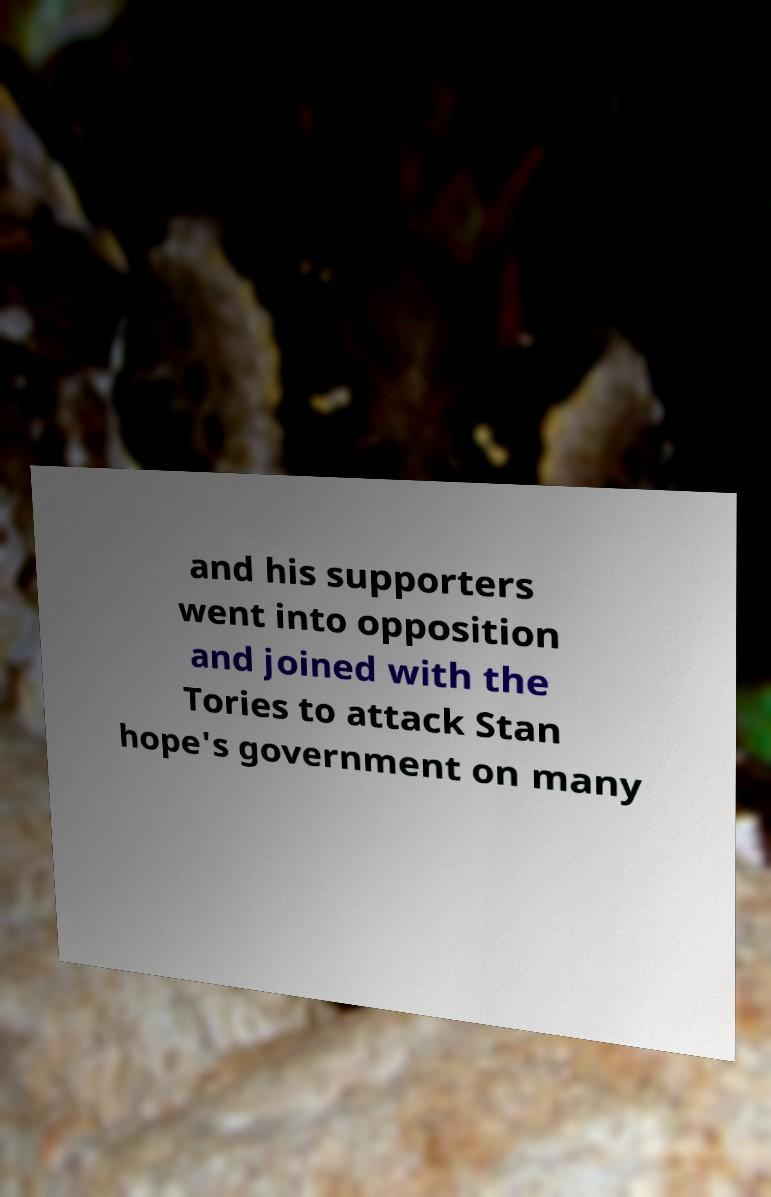For documentation purposes, I need the text within this image transcribed. Could you provide that? and his supporters went into opposition and joined with the Tories to attack Stan hope's government on many 